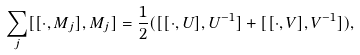<formula> <loc_0><loc_0><loc_500><loc_500>\sum _ { j } [ [ \cdot , M _ { j } ] , M _ { j } ] = \frac { 1 } { 2 } ( [ [ \cdot , U ] , U ^ { - 1 } ] + [ [ \cdot , V ] , V ^ { - 1 } ] ) ,</formula> 